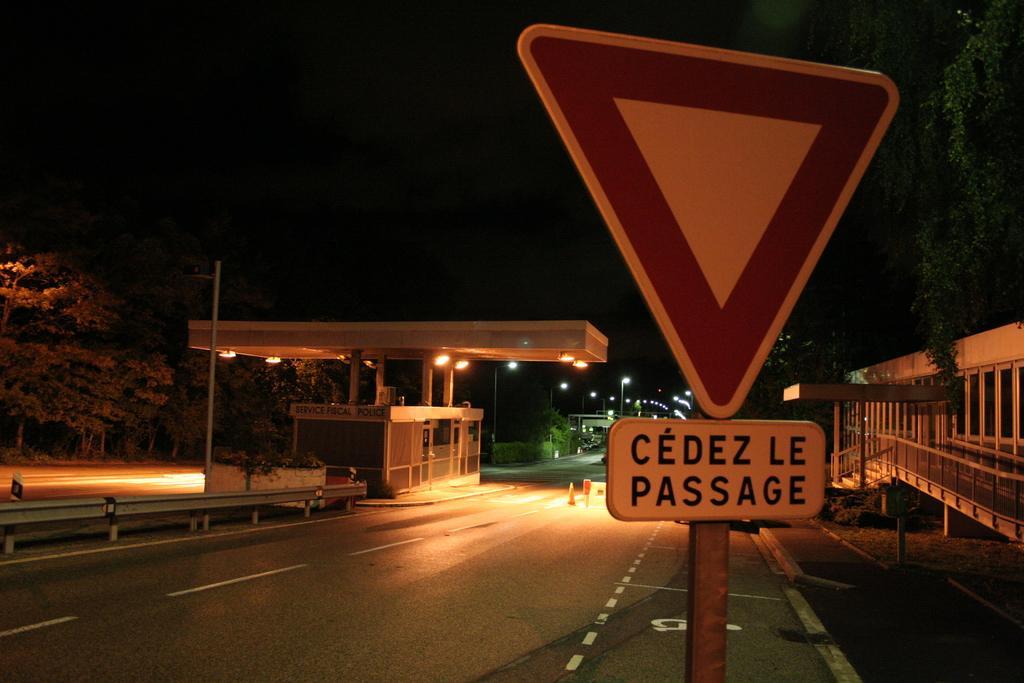Please provide a concise description of this image. In this image we can see a sign board. In the background, we can see roads, buildings, railing, poles, lights, pavement and trees. 